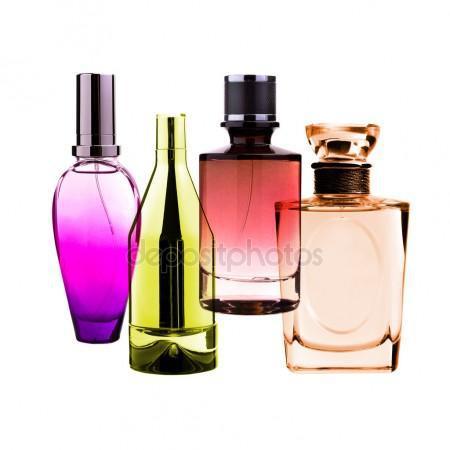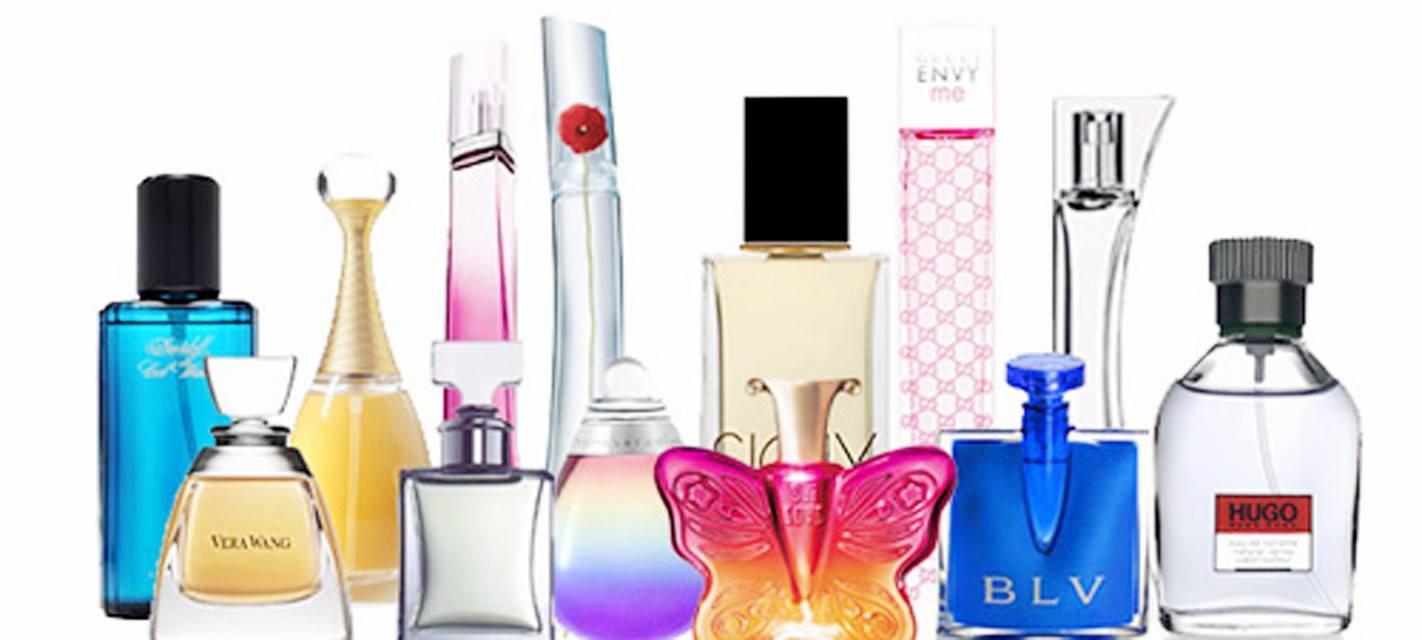The first image is the image on the left, the second image is the image on the right. Considering the images on both sides, is "The left image contains only two fragrance-related objects, which are side-by-side but not touching and include a lavender bottle with a metallic element." valid? Answer yes or no. No. The first image is the image on the left, the second image is the image on the right. Analyze the images presented: Is the assertion "There is a bottle shaped like an animal." valid? Answer yes or no. Yes. 